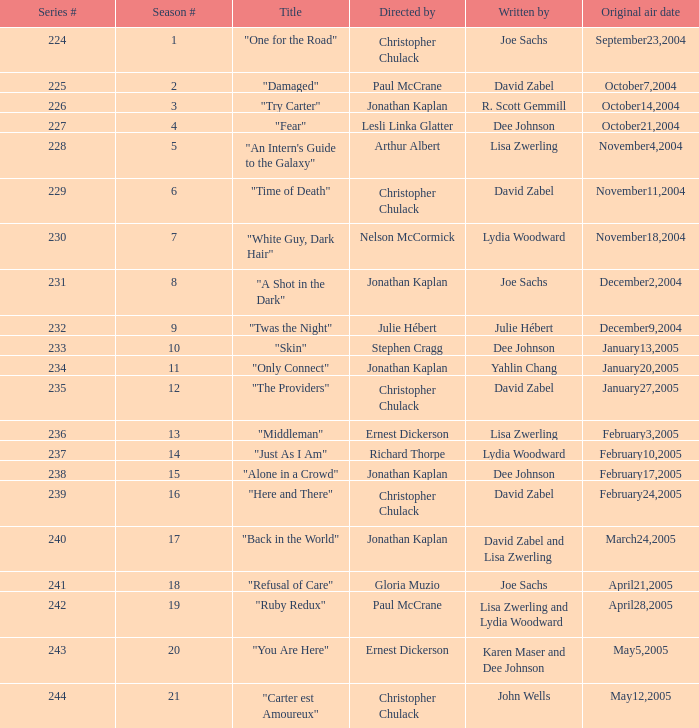Name who directed the episode for the series number 236 Ernest Dickerson. Can you give me this table as a dict? {'header': ['Series #', 'Season #', 'Title', 'Directed by', 'Written by', 'Original air date'], 'rows': [['224', '1', '"One for the Road"', 'Christopher Chulack', 'Joe Sachs', 'September23,2004'], ['225', '2', '"Damaged"', 'Paul McCrane', 'David Zabel', 'October7,2004'], ['226', '3', '"Try Carter"', 'Jonathan Kaplan', 'R. Scott Gemmill', 'October14,2004'], ['227', '4', '"Fear"', 'Lesli Linka Glatter', 'Dee Johnson', 'October21,2004'], ['228', '5', '"An Intern\'s Guide to the Galaxy"', 'Arthur Albert', 'Lisa Zwerling', 'November4,2004'], ['229', '6', '"Time of Death"', 'Christopher Chulack', 'David Zabel', 'November11,2004'], ['230', '7', '"White Guy, Dark Hair"', 'Nelson McCormick', 'Lydia Woodward', 'November18,2004'], ['231', '8', '"A Shot in the Dark"', 'Jonathan Kaplan', 'Joe Sachs', 'December2,2004'], ['232', '9', '"Twas the Night"', 'Julie Hébert', 'Julie Hébert', 'December9,2004'], ['233', '10', '"Skin"', 'Stephen Cragg', 'Dee Johnson', 'January13,2005'], ['234', '11', '"Only Connect"', 'Jonathan Kaplan', 'Yahlin Chang', 'January20,2005'], ['235', '12', '"The Providers"', 'Christopher Chulack', 'David Zabel', 'January27,2005'], ['236', '13', '"Middleman"', 'Ernest Dickerson', 'Lisa Zwerling', 'February3,2005'], ['237', '14', '"Just As I Am"', 'Richard Thorpe', 'Lydia Woodward', 'February10,2005'], ['238', '15', '"Alone in a Crowd"', 'Jonathan Kaplan', 'Dee Johnson', 'February17,2005'], ['239', '16', '"Here and There"', 'Christopher Chulack', 'David Zabel', 'February24,2005'], ['240', '17', '"Back in the World"', 'Jonathan Kaplan', 'David Zabel and Lisa Zwerling', 'March24,2005'], ['241', '18', '"Refusal of Care"', 'Gloria Muzio', 'Joe Sachs', 'April21,2005'], ['242', '19', '"Ruby Redux"', 'Paul McCrane', 'Lisa Zwerling and Lydia Woodward', 'April28,2005'], ['243', '20', '"You Are Here"', 'Ernest Dickerson', 'Karen Maser and Dee Johnson', 'May5,2005'], ['244', '21', '"Carter est Amoureux"', 'Christopher Chulack', 'John Wells', 'May12,2005']]} 